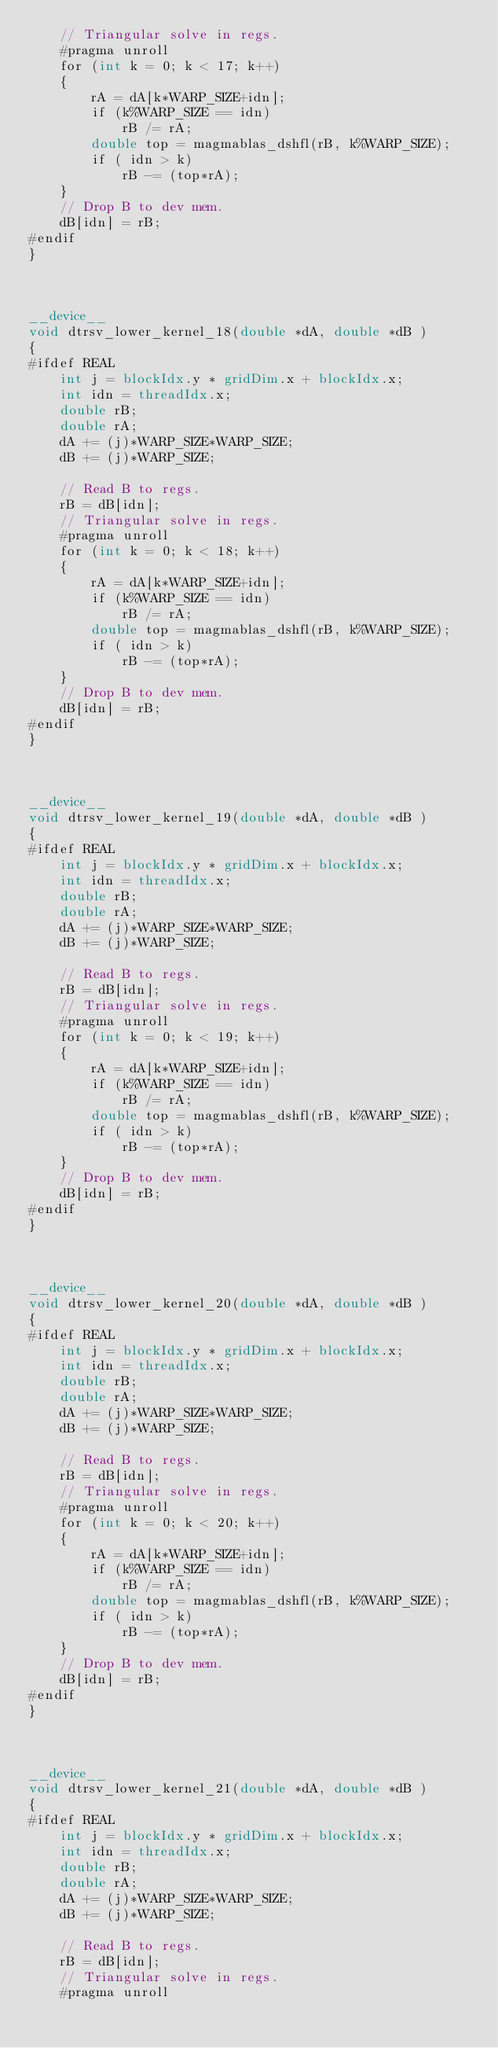<code> <loc_0><loc_0><loc_500><loc_500><_Cuda_>    // Triangular solve in regs.
    #pragma unroll
    for (int k = 0; k < 17; k++)
    {
        rA = dA[k*WARP_SIZE+idn];
        if (k%WARP_SIZE == idn)
            rB /= rA;
        double top = magmablas_dshfl(rB, k%WARP_SIZE);
        if ( idn > k)
            rB -= (top*rA);
    }
    // Drop B to dev mem.
    dB[idn] = rB;
#endif
}



__device__
void dtrsv_lower_kernel_18(double *dA, double *dB )
{
#ifdef REAL
    int j = blockIdx.y * gridDim.x + blockIdx.x;
    int idn = threadIdx.x;
    double rB;
    double rA;
    dA += (j)*WARP_SIZE*WARP_SIZE;
    dB += (j)*WARP_SIZE;

    // Read B to regs.
    rB = dB[idn];
    // Triangular solve in regs.
    #pragma unroll
    for (int k = 0; k < 18; k++)
    {
        rA = dA[k*WARP_SIZE+idn];
        if (k%WARP_SIZE == idn)
            rB /= rA;
        double top = magmablas_dshfl(rB, k%WARP_SIZE);
        if ( idn > k)
            rB -= (top*rA);
    }
    // Drop B to dev mem.
    dB[idn] = rB;
#endif
}



__device__
void dtrsv_lower_kernel_19(double *dA, double *dB )
{
#ifdef REAL
    int j = blockIdx.y * gridDim.x + blockIdx.x;
    int idn = threadIdx.x;
    double rB;
    double rA;
    dA += (j)*WARP_SIZE*WARP_SIZE;
    dB += (j)*WARP_SIZE;

    // Read B to regs.
    rB = dB[idn];
    // Triangular solve in regs.
    #pragma unroll
    for (int k = 0; k < 19; k++)
    {
        rA = dA[k*WARP_SIZE+idn];
        if (k%WARP_SIZE == idn)
            rB /= rA;
        double top = magmablas_dshfl(rB, k%WARP_SIZE);
        if ( idn > k)
            rB -= (top*rA);
    }
    // Drop B to dev mem.
    dB[idn] = rB;
#endif
}



__device__
void dtrsv_lower_kernel_20(double *dA, double *dB )
{
#ifdef REAL
    int j = blockIdx.y * gridDim.x + blockIdx.x;
    int idn = threadIdx.x;
    double rB;
    double rA;
    dA += (j)*WARP_SIZE*WARP_SIZE;
    dB += (j)*WARP_SIZE;

    // Read B to regs.
    rB = dB[idn];
    // Triangular solve in regs.
    #pragma unroll
    for (int k = 0; k < 20; k++)
    {
        rA = dA[k*WARP_SIZE+idn];
        if (k%WARP_SIZE == idn)
            rB /= rA;
        double top = magmablas_dshfl(rB, k%WARP_SIZE);
        if ( idn > k)
            rB -= (top*rA);
    }
    // Drop B to dev mem.
    dB[idn] = rB;
#endif
}



__device__
void dtrsv_lower_kernel_21(double *dA, double *dB )
{
#ifdef REAL
    int j = blockIdx.y * gridDim.x + blockIdx.x;
    int idn = threadIdx.x;
    double rB;
    double rA;
    dA += (j)*WARP_SIZE*WARP_SIZE;
    dB += (j)*WARP_SIZE;

    // Read B to regs.
    rB = dB[idn];
    // Triangular solve in regs.
    #pragma unroll</code> 